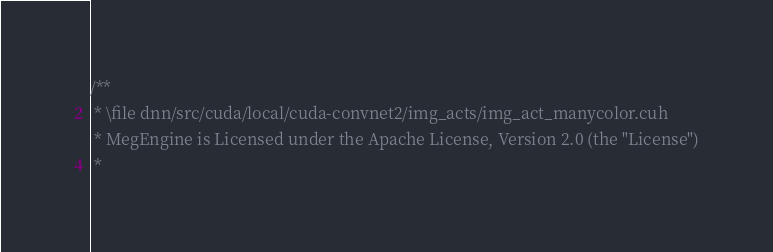<code> <loc_0><loc_0><loc_500><loc_500><_Cuda_>/**
 * \file dnn/src/cuda/local/cuda-convnet2/img_acts/img_act_manycolor.cuh
 * MegEngine is Licensed under the Apache License, Version 2.0 (the "License")
 *</code> 